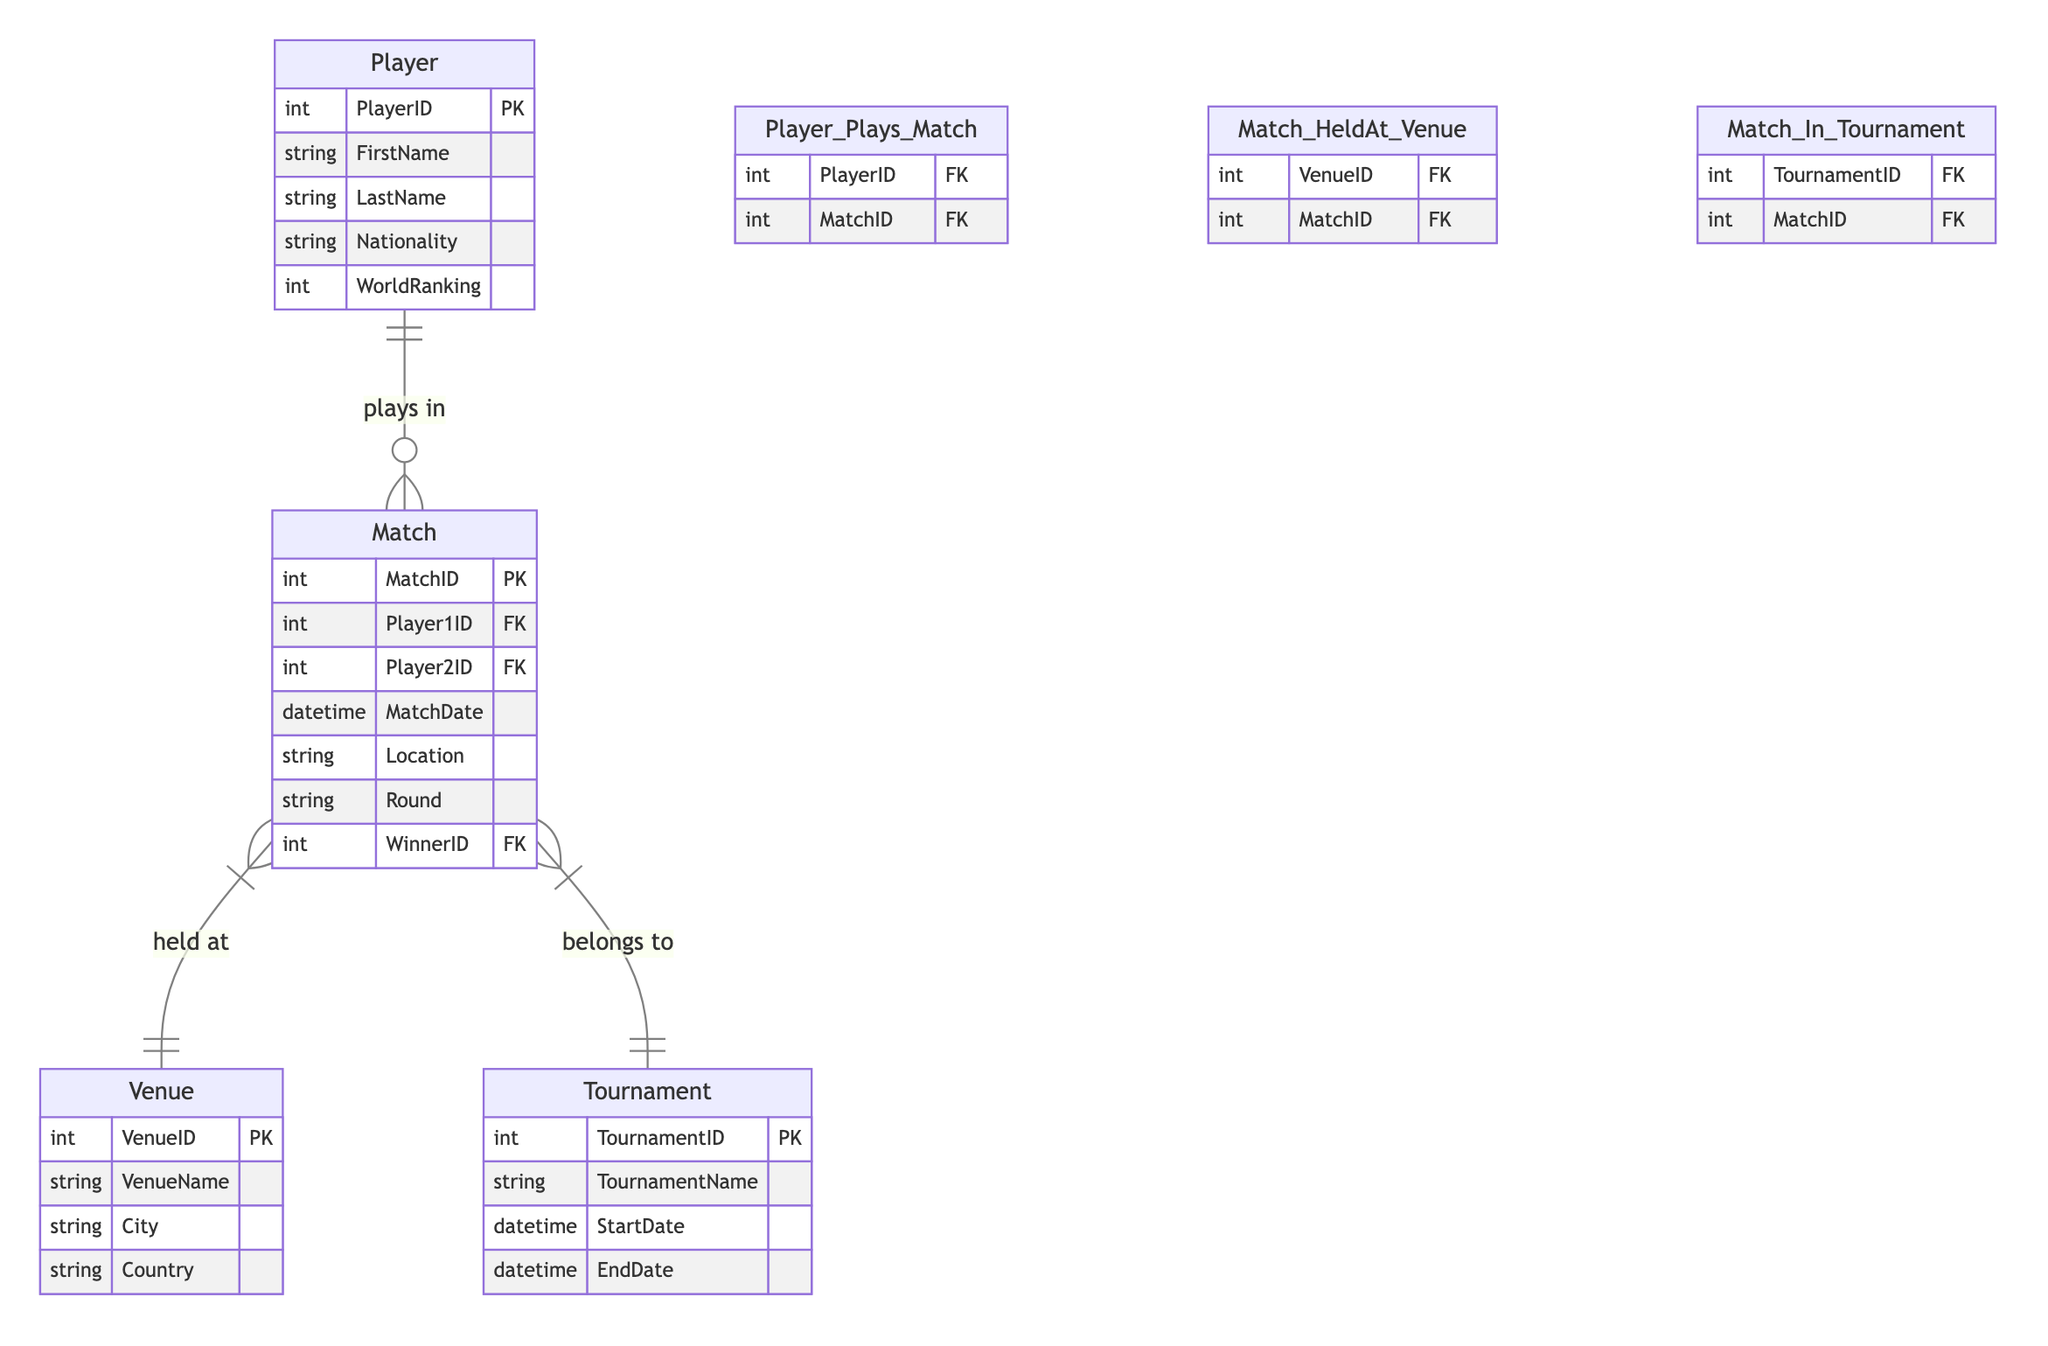What is the primary key of the Player entity? The primary key of the Player entity is PlayerID, which uniquely identifies each player in the database.
Answer: PlayerID How many attributes does the Match entity have? The Match entity has six attributes: MatchID, Player1ID, Player2ID, MatchDate, Location, Round, and WinnerID.
Answer: Six What type of relationship exists between Match and Venue? The relationship between Match and Venue is many-to-one, indicating that multiple matches can be held at a single venue, but each match is held in only one venue.
Answer: Many-to-one Which entity contains the attribute 'TournamentName'? The attribute 'TournamentName' is contained within the Tournament entity, which holds all tournament-related information.
Answer: Tournament What is the foreign key in the Player_Plays_Match relationship? In the Player_Plays_Match relationship, both PlayerID and MatchID serve as foreign keys linking players to their respective matches.
Answer: PlayerID and MatchID How many foreign keys are present in the Match entity? The Match entity contains three foreign keys: Player1ID, Player2ID, and WinnerID, which relate players to the match details.
Answer: Three Which entity can a Match belong to? A Match can belong to a Tournament, establishing a connection between the match and its specific tournament.
Answer: Tournament What is the location attribute associated with in the Match entity? The location attribute in the Match entity indicates the physical location where the match is held, corresponding to a venue.
Answer: Venue Which entities participate in the Player_Plays_Match relationship? The Player_Plays_Match relationship involves two entities: Player and Match, illustrating the connection between players and their respective matches.
Answer: Player and Match 